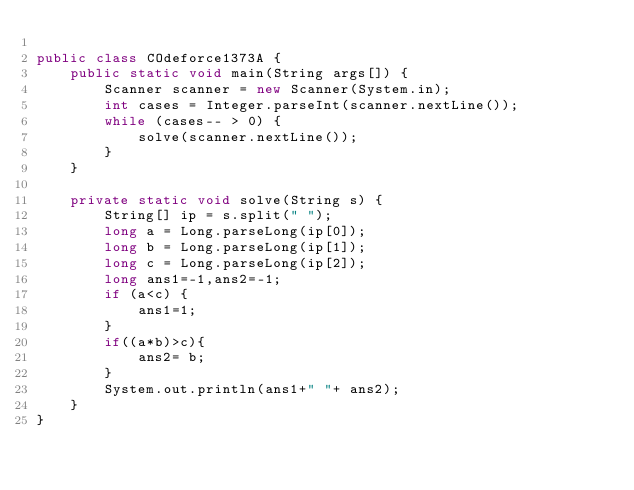<code> <loc_0><loc_0><loc_500><loc_500><_Java_>
public class COdeforce1373A {
    public static void main(String args[]) {
        Scanner scanner = new Scanner(System.in);
        int cases = Integer.parseInt(scanner.nextLine());
        while (cases-- > 0) {
            solve(scanner.nextLine());
        }
    }

    private static void solve(String s) {
        String[] ip = s.split(" ");
        long a = Long.parseLong(ip[0]);
        long b = Long.parseLong(ip[1]);
        long c = Long.parseLong(ip[2]);
        long ans1=-1,ans2=-1;
        if (a<c) {
            ans1=1;
        }
        if((a*b)>c){
            ans2= b;
        }
        System.out.println(ans1+" "+ ans2);
    }
}
</code> 